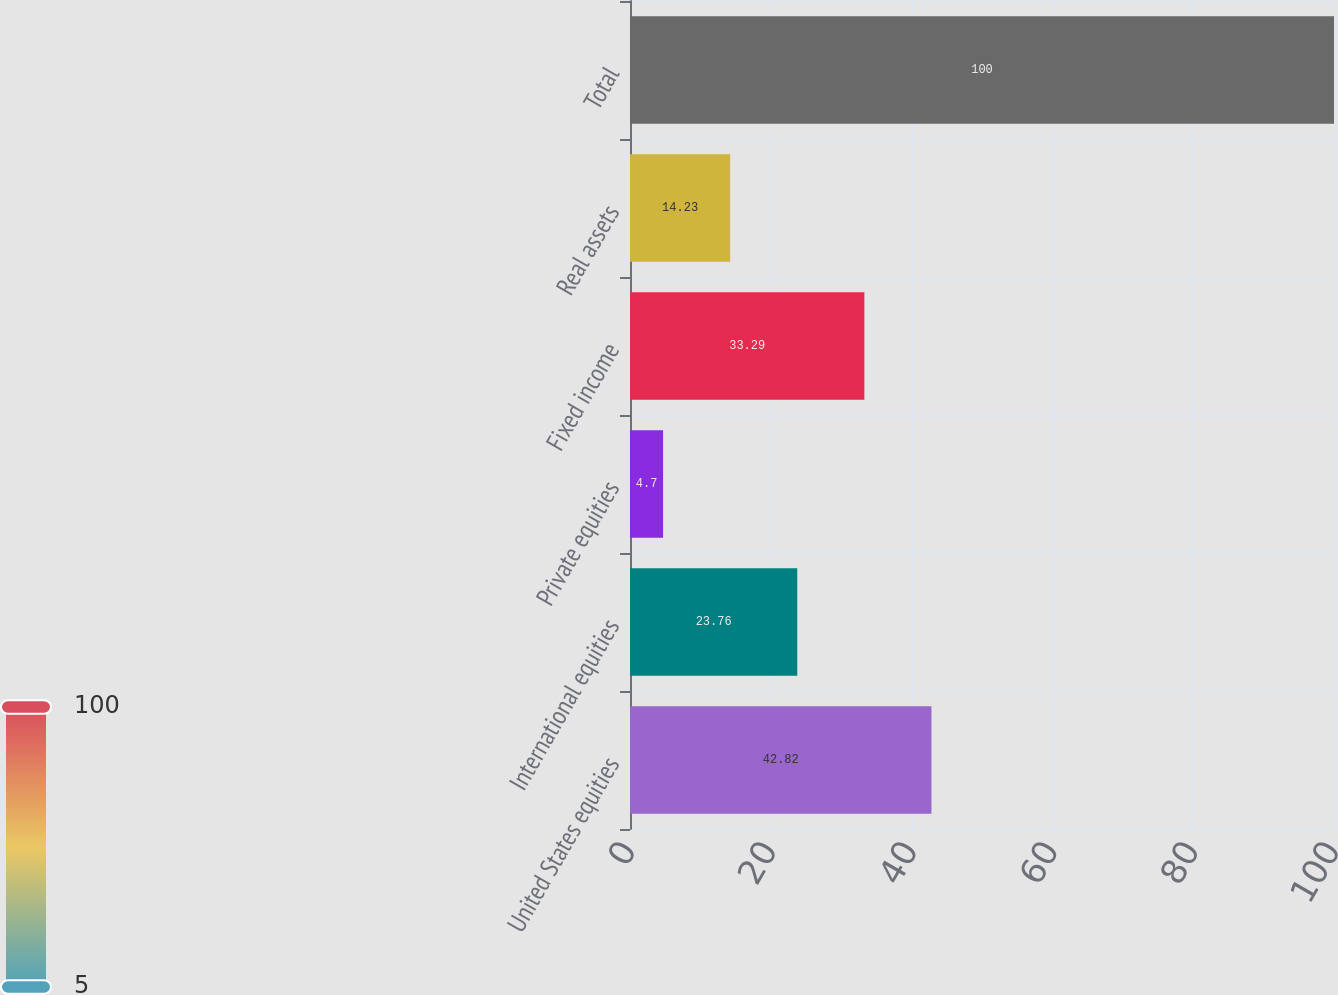Convert chart. <chart><loc_0><loc_0><loc_500><loc_500><bar_chart><fcel>United States equities<fcel>International equities<fcel>Private equities<fcel>Fixed income<fcel>Real assets<fcel>Total<nl><fcel>42.82<fcel>23.76<fcel>4.7<fcel>33.29<fcel>14.23<fcel>100<nl></chart> 